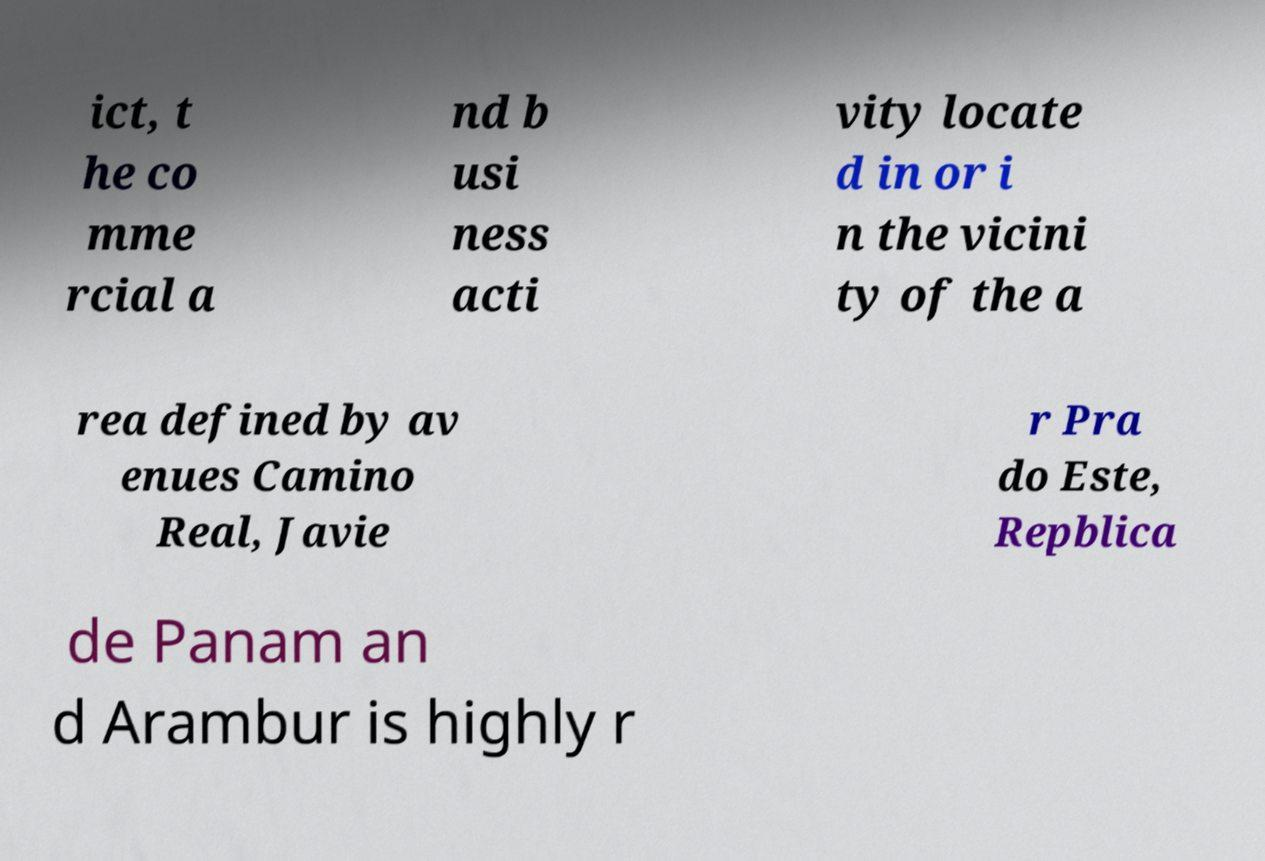Please read and relay the text visible in this image. What does it say? ict, t he co mme rcial a nd b usi ness acti vity locate d in or i n the vicini ty of the a rea defined by av enues Camino Real, Javie r Pra do Este, Repblica de Panam an d Arambur is highly r 